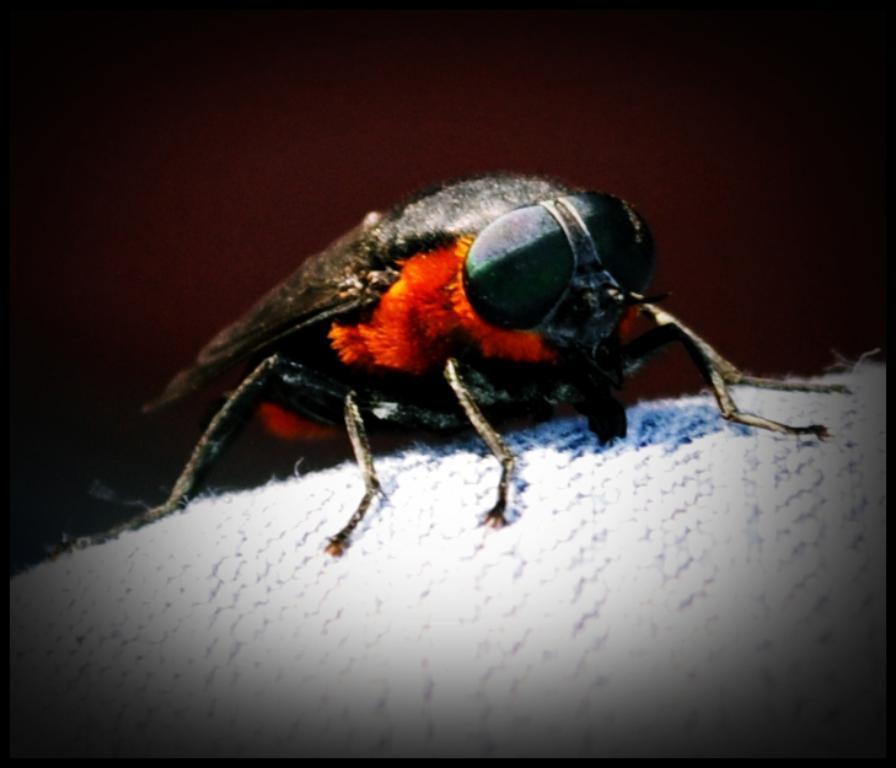Please provide a concise description of this image. This picture consists of a hornet in the center of the image. 